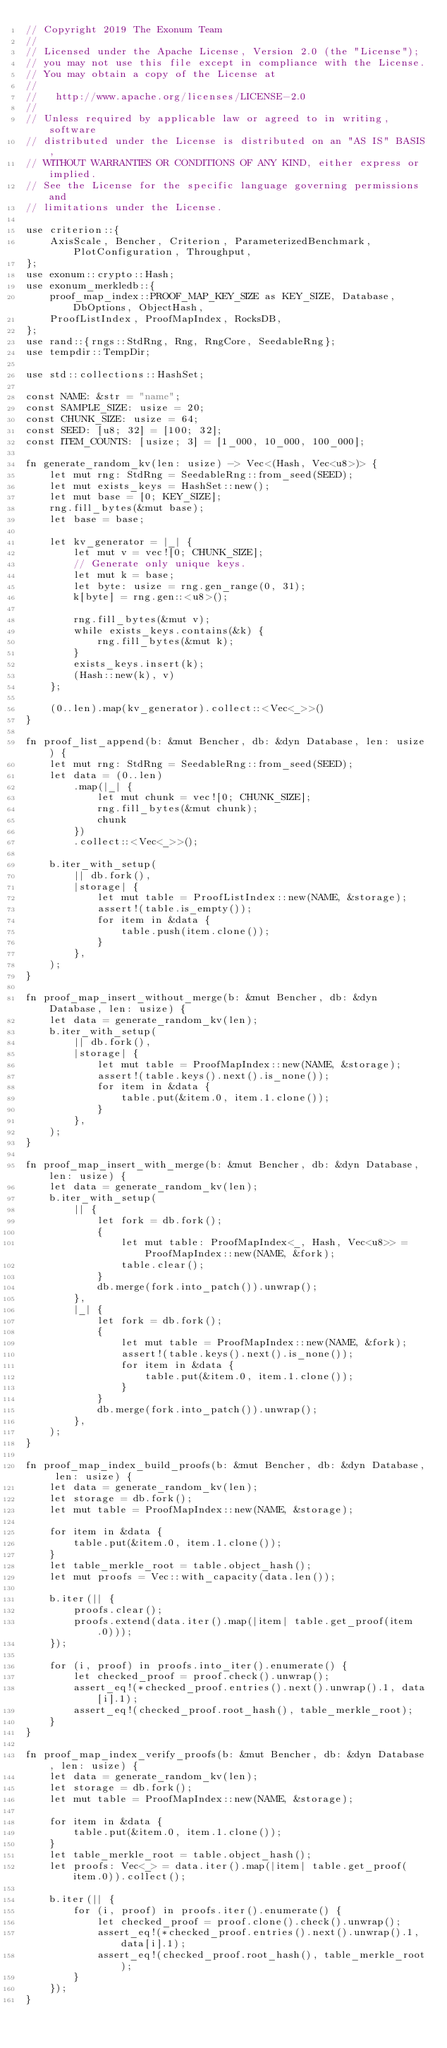<code> <loc_0><loc_0><loc_500><loc_500><_Rust_>// Copyright 2019 The Exonum Team
//
// Licensed under the Apache License, Version 2.0 (the "License");
// you may not use this file except in compliance with the License.
// You may obtain a copy of the License at
//
//   http://www.apache.org/licenses/LICENSE-2.0
//
// Unless required by applicable law or agreed to in writing, software
// distributed under the License is distributed on an "AS IS" BASIS,
// WITHOUT WARRANTIES OR CONDITIONS OF ANY KIND, either express or implied.
// See the License for the specific language governing permissions and
// limitations under the License.

use criterion::{
    AxisScale, Bencher, Criterion, ParameterizedBenchmark, PlotConfiguration, Throughput,
};
use exonum::crypto::Hash;
use exonum_merkledb::{
    proof_map_index::PROOF_MAP_KEY_SIZE as KEY_SIZE, Database, DbOptions, ObjectHash,
    ProofListIndex, ProofMapIndex, RocksDB,
};
use rand::{rngs::StdRng, Rng, RngCore, SeedableRng};
use tempdir::TempDir;

use std::collections::HashSet;

const NAME: &str = "name";
const SAMPLE_SIZE: usize = 20;
const CHUNK_SIZE: usize = 64;
const SEED: [u8; 32] = [100; 32];
const ITEM_COUNTS: [usize; 3] = [1_000, 10_000, 100_000];

fn generate_random_kv(len: usize) -> Vec<(Hash, Vec<u8>)> {
    let mut rng: StdRng = SeedableRng::from_seed(SEED);
    let mut exists_keys = HashSet::new();
    let mut base = [0; KEY_SIZE];
    rng.fill_bytes(&mut base);
    let base = base;

    let kv_generator = |_| {
        let mut v = vec![0; CHUNK_SIZE];
        // Generate only unique keys.
        let mut k = base;
        let byte: usize = rng.gen_range(0, 31);
        k[byte] = rng.gen::<u8>();

        rng.fill_bytes(&mut v);
        while exists_keys.contains(&k) {
            rng.fill_bytes(&mut k);
        }
        exists_keys.insert(k);
        (Hash::new(k), v)
    };

    (0..len).map(kv_generator).collect::<Vec<_>>()
}

fn proof_list_append(b: &mut Bencher, db: &dyn Database, len: usize) {
    let mut rng: StdRng = SeedableRng::from_seed(SEED);
    let data = (0..len)
        .map(|_| {
            let mut chunk = vec![0; CHUNK_SIZE];
            rng.fill_bytes(&mut chunk);
            chunk
        })
        .collect::<Vec<_>>();

    b.iter_with_setup(
        || db.fork(),
        |storage| {
            let mut table = ProofListIndex::new(NAME, &storage);
            assert!(table.is_empty());
            for item in &data {
                table.push(item.clone());
            }
        },
    );
}

fn proof_map_insert_without_merge(b: &mut Bencher, db: &dyn Database, len: usize) {
    let data = generate_random_kv(len);
    b.iter_with_setup(
        || db.fork(),
        |storage| {
            let mut table = ProofMapIndex::new(NAME, &storage);
            assert!(table.keys().next().is_none());
            for item in &data {
                table.put(&item.0, item.1.clone());
            }
        },
    );
}

fn proof_map_insert_with_merge(b: &mut Bencher, db: &dyn Database, len: usize) {
    let data = generate_random_kv(len);
    b.iter_with_setup(
        || {
            let fork = db.fork();
            {
                let mut table: ProofMapIndex<_, Hash, Vec<u8>> = ProofMapIndex::new(NAME, &fork);
                table.clear();
            }
            db.merge(fork.into_patch()).unwrap();
        },
        |_| {
            let fork = db.fork();
            {
                let mut table = ProofMapIndex::new(NAME, &fork);
                assert!(table.keys().next().is_none());
                for item in &data {
                    table.put(&item.0, item.1.clone());
                }
            }
            db.merge(fork.into_patch()).unwrap();
        },
    );
}

fn proof_map_index_build_proofs(b: &mut Bencher, db: &dyn Database, len: usize) {
    let data = generate_random_kv(len);
    let storage = db.fork();
    let mut table = ProofMapIndex::new(NAME, &storage);

    for item in &data {
        table.put(&item.0, item.1.clone());
    }
    let table_merkle_root = table.object_hash();
    let mut proofs = Vec::with_capacity(data.len());

    b.iter(|| {
        proofs.clear();
        proofs.extend(data.iter().map(|item| table.get_proof(item.0)));
    });

    for (i, proof) in proofs.into_iter().enumerate() {
        let checked_proof = proof.check().unwrap();
        assert_eq!(*checked_proof.entries().next().unwrap().1, data[i].1);
        assert_eq!(checked_proof.root_hash(), table_merkle_root);
    }
}

fn proof_map_index_verify_proofs(b: &mut Bencher, db: &dyn Database, len: usize) {
    let data = generate_random_kv(len);
    let storage = db.fork();
    let mut table = ProofMapIndex::new(NAME, &storage);

    for item in &data {
        table.put(&item.0, item.1.clone());
    }
    let table_merkle_root = table.object_hash();
    let proofs: Vec<_> = data.iter().map(|item| table.get_proof(item.0)).collect();

    b.iter(|| {
        for (i, proof) in proofs.iter().enumerate() {
            let checked_proof = proof.clone().check().unwrap();
            assert_eq!(*checked_proof.entries().next().unwrap().1, data[i].1);
            assert_eq!(checked_proof.root_hash(), table_merkle_root);
        }
    });
}
</code> 